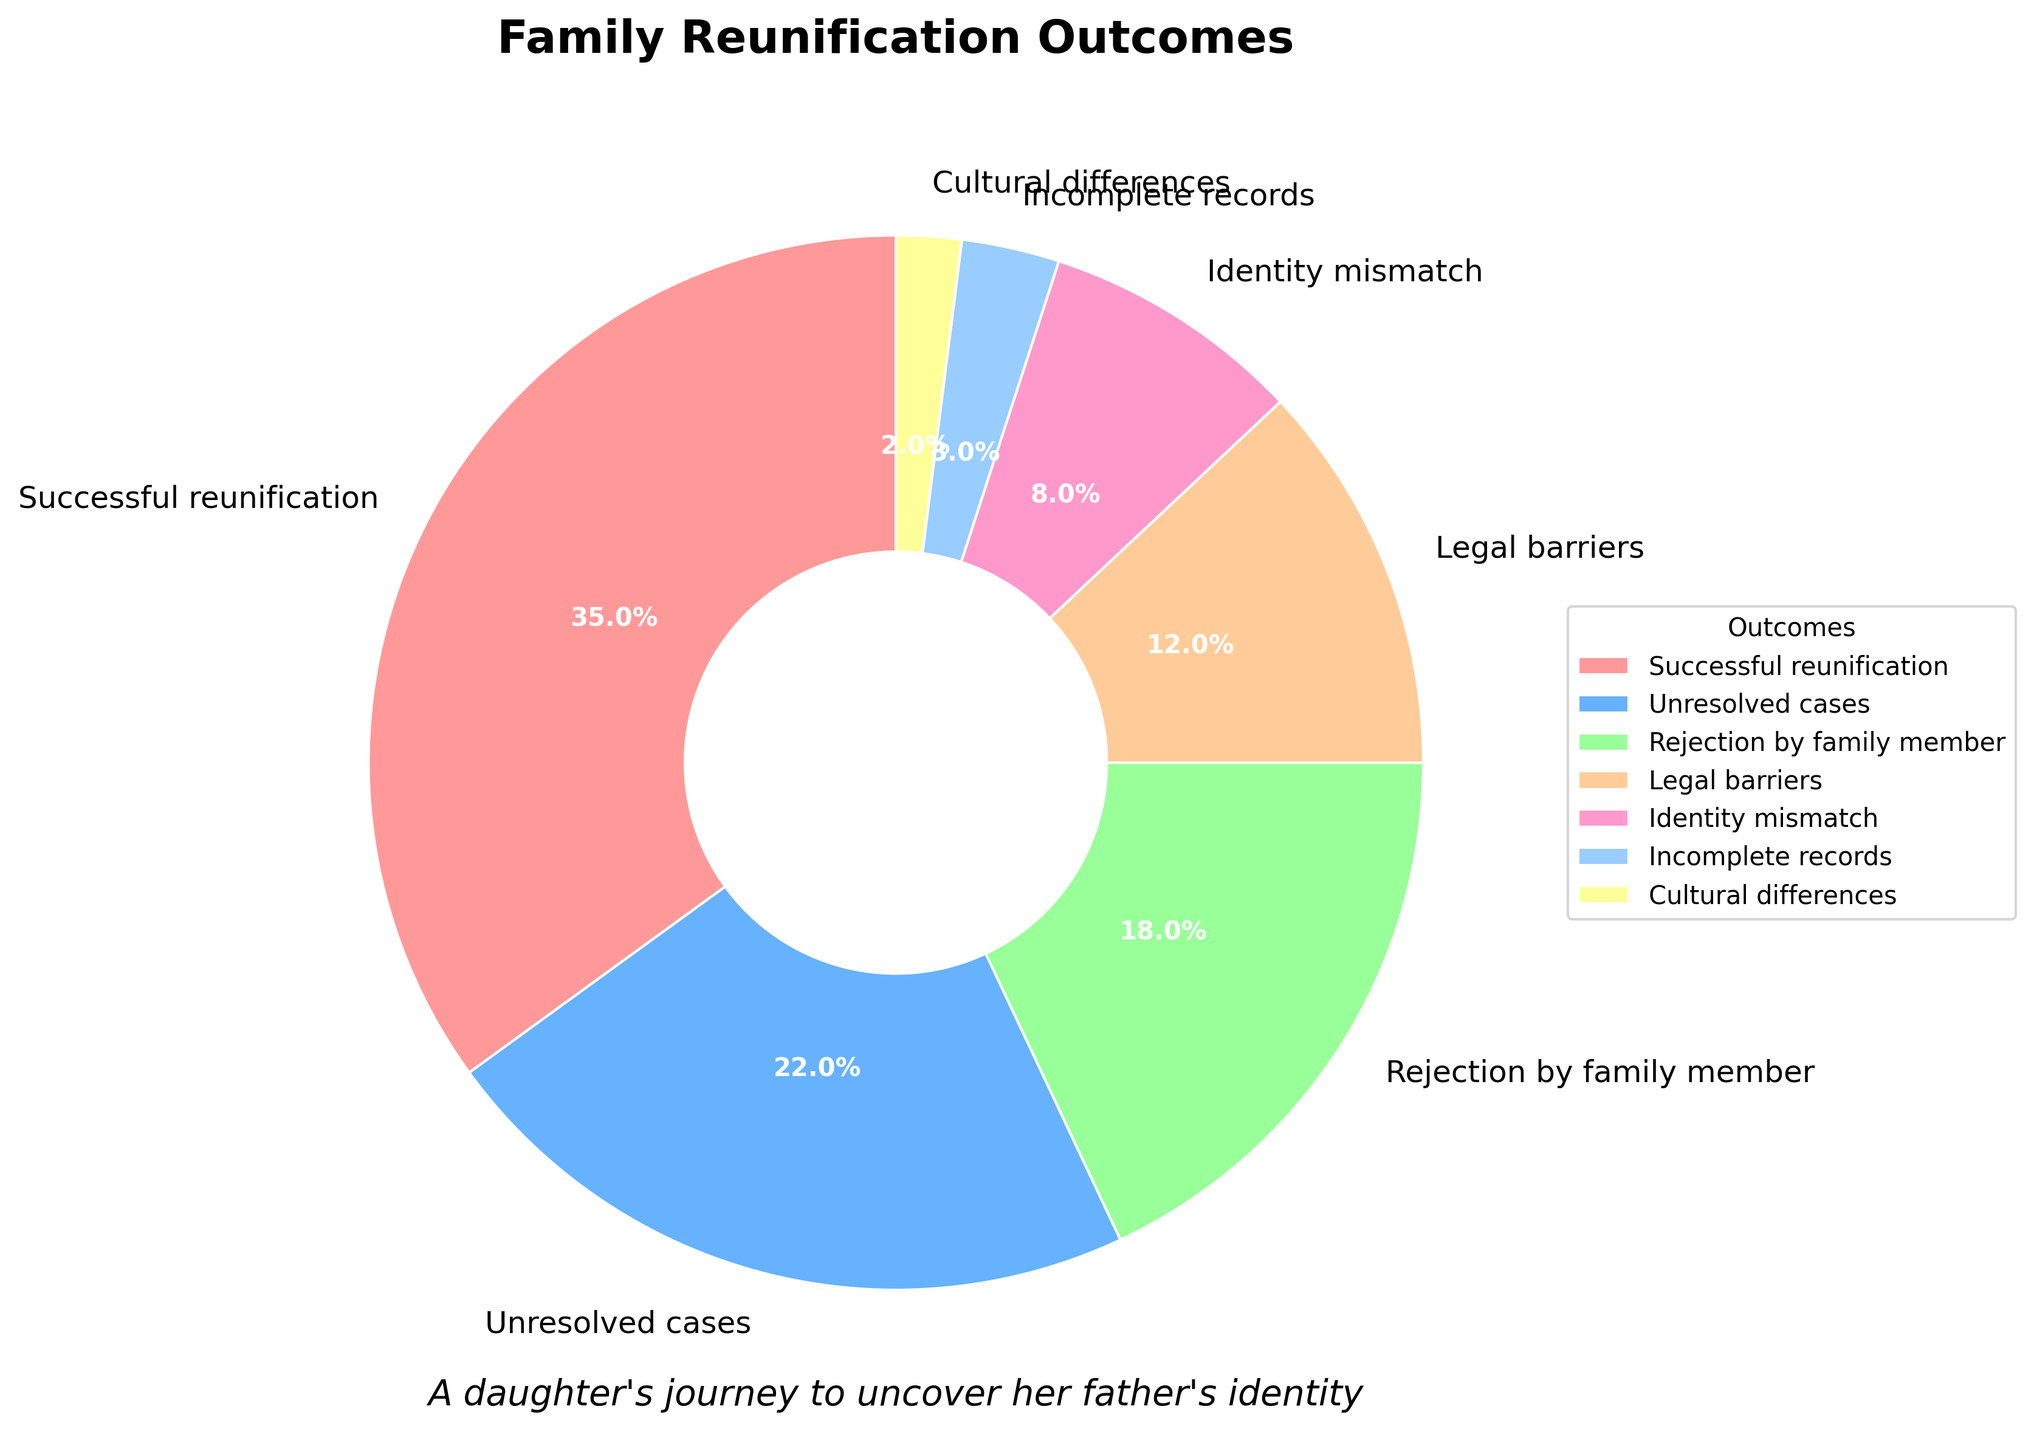Which outcome has the highest percentage? By looking at the slices of the pie chart, the "Successful reunification" section appears the largest which signifies it has the highest percentage at 35%.
Answer: Successful reunification Which outcome has the smallest percentage? By looking at the slices of the pie chart, the "Cultural differences" section appears the smallest which signifies it has the smallest percentage at 2%.
Answer: Cultural differences What is the combined percentage of unsuccessful outcomes (Rejection by family member, Legal barriers, Identity mismatch, Incomplete records, Cultural differences)? Add the percentages of Rejection by family member (18%), Legal barriers (12%), Identity mismatch (8%), Incomplete records (3%), and Cultural differences (2%). The sum is 18 + 12 + 8 + 3 + 2 = 43%.
Answer: 43% How does the percentage of unresolved cases compare to that of legal barriers? The pie chart shows that unresolved cases have a percentage of 22%, while legal barriers have a percentage of 12%, meaning unresolved cases have a higher percentage.
Answer: Unresolved cases have a higher percentage Which slice is colored red in the pie chart? The red slice corresponds to the "Successful reunification" outcome as observed from the pie chart.
Answer: Successful reunification What is the difference in percentage between identity mismatch and incomplete records? Subtract the percentage of incomplete records (3%) from the percentage of identity mismatch (8%). The difference is 8% - 3% = 5%.
Answer: 5% How many outcomes have a percentage greater than 10%? By examining the pie chart, the outcomes with a percentage greater than 10% are Successful reunification (35%), Unresolved cases (22%), Rejection by family member (18%), and Legal barriers (12%). This results in 4 outcomes.
Answer: 4 outcomes What is the average percentage of unresolved cases, legal barriers, and cultural differences? Add the percentages of unresolved cases (22%), legal barriers (12%), and cultural differences (2%) and divide by the number of outcomes. (22 + 12 + 2) / 3 = 12%.
Answer: 12% Is the percentage for rejection by family member higher than that for legal barriers? From the pie chart, the percentage for rejection by family member is 18%, while the percentage for legal barriers is 12%. Therefore, rejection by family member has a higher percentage.
Answer: Yes What is the median percentage among the given outcomes? List the percentages in ascending order: 2%, 3%, 8%, 12%, 18%, 22%, 35%. Since there are 7 outcomes, the median is the 4th value in the list, which is 12%.
Answer: 12% 